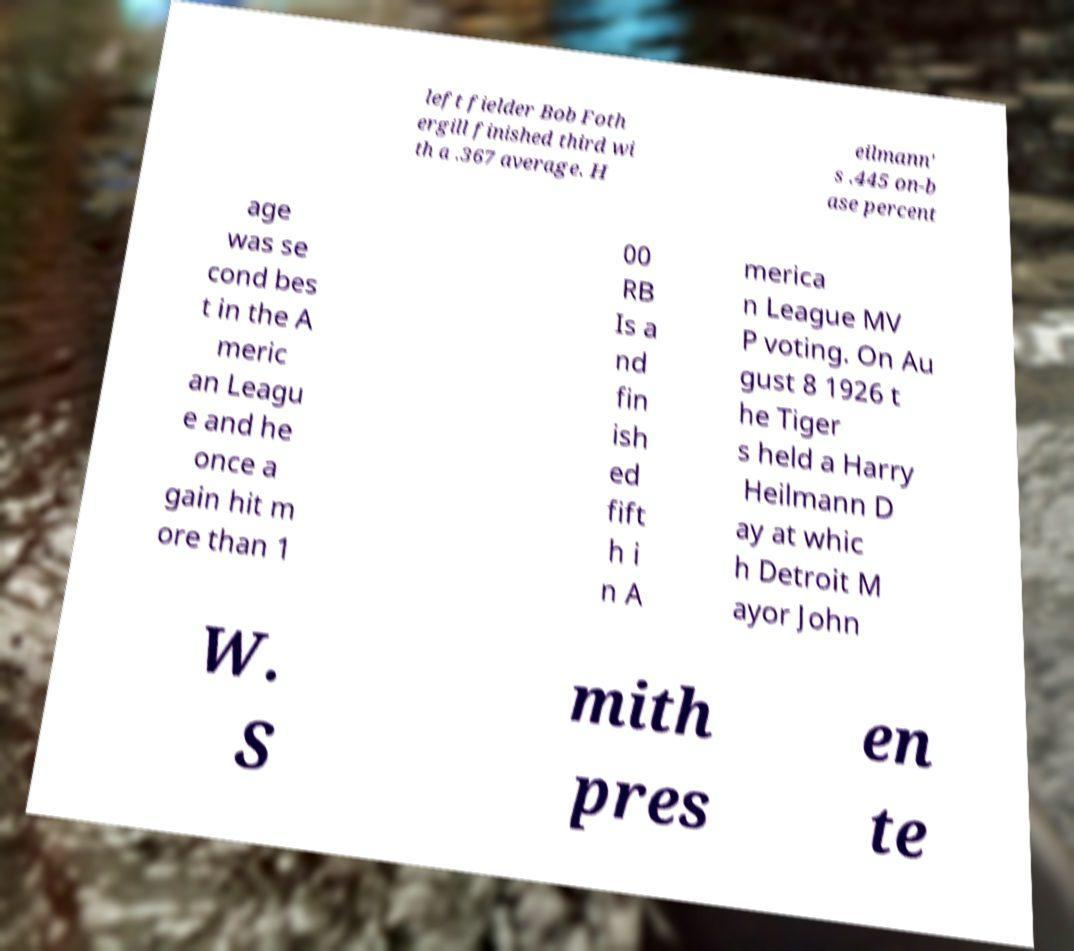Could you assist in decoding the text presented in this image and type it out clearly? left fielder Bob Foth ergill finished third wi th a .367 average. H eilmann' s .445 on-b ase percent age was se cond bes t in the A meric an Leagu e and he once a gain hit m ore than 1 00 RB Is a nd fin ish ed fift h i n A merica n League MV P voting. On Au gust 8 1926 t he Tiger s held a Harry Heilmann D ay at whic h Detroit M ayor John W. S mith pres en te 